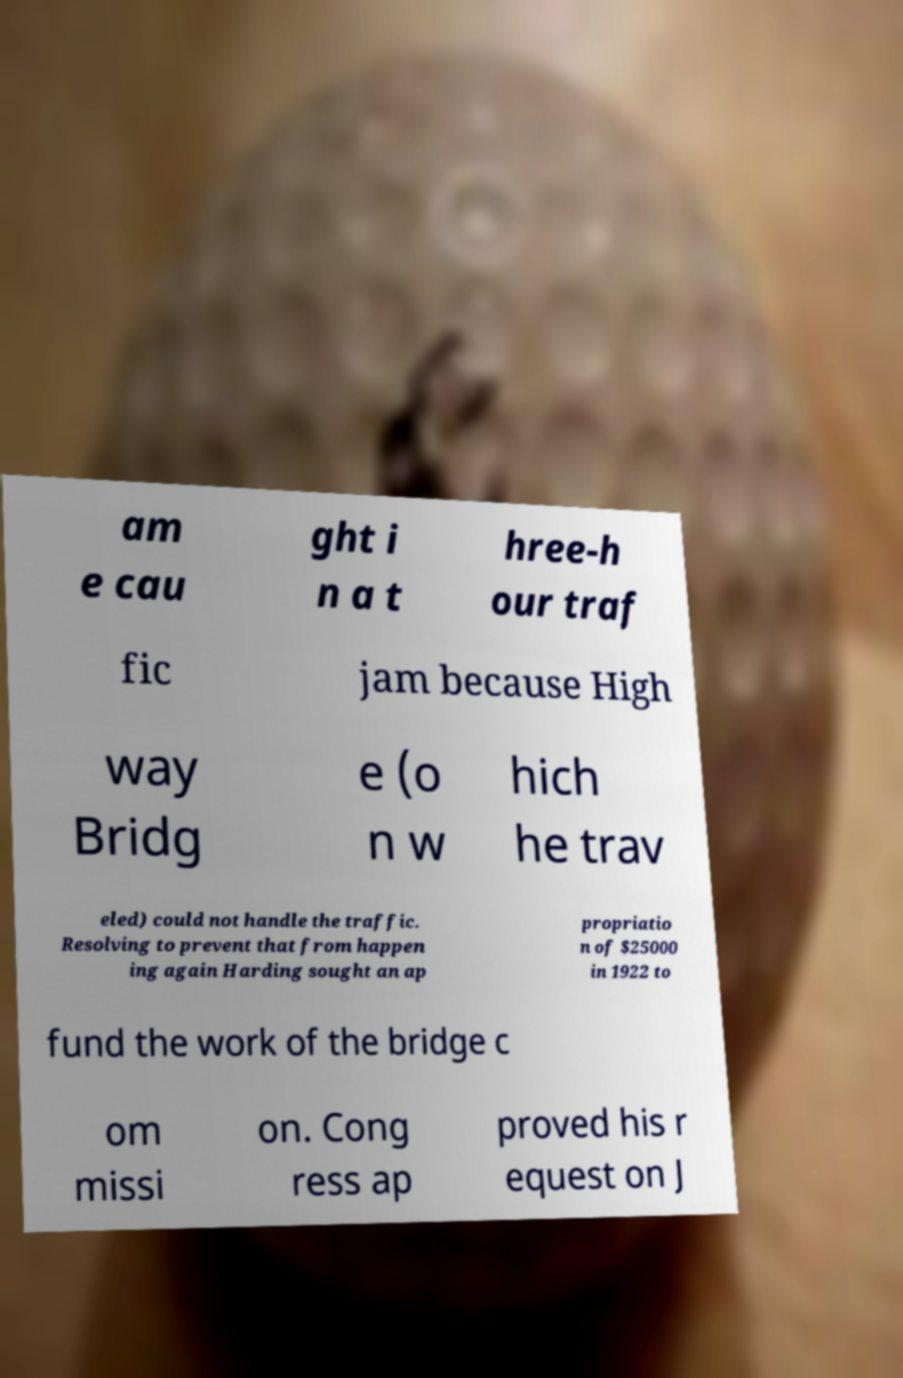Could you assist in decoding the text presented in this image and type it out clearly? am e cau ght i n a t hree-h our traf fic jam because High way Bridg e (o n w hich he trav eled) could not handle the traffic. Resolving to prevent that from happen ing again Harding sought an ap propriatio n of $25000 in 1922 to fund the work of the bridge c om missi on. Cong ress ap proved his r equest on J 